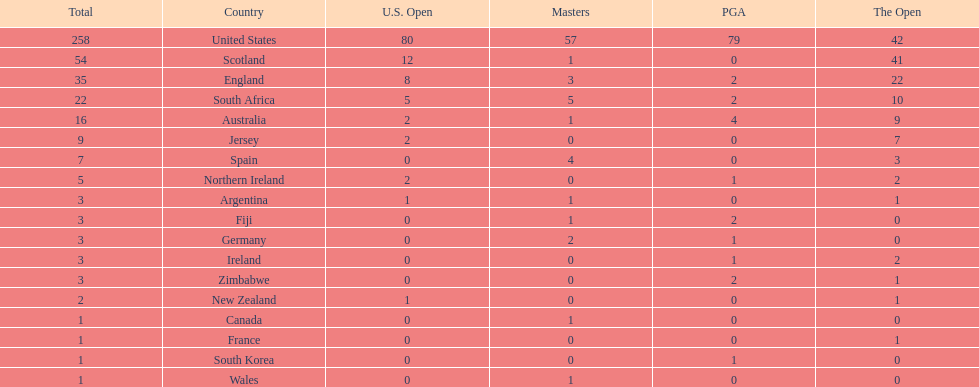Which country has the most pga championships. United States. Can you give me this table as a dict? {'header': ['Total', 'Country', 'U.S. Open', 'Masters', 'PGA', 'The Open'], 'rows': [['258', 'United States', '80', '57', '79', '42'], ['54', 'Scotland', '12', '1', '0', '41'], ['35', 'England', '8', '3', '2', '22'], ['22', 'South Africa', '5', '5', '2', '10'], ['16', 'Australia', '2', '1', '4', '9'], ['9', 'Jersey', '2', '0', '0', '7'], ['7', 'Spain', '0', '4', '0', '3'], ['5', 'Northern Ireland', '2', '0', '1', '2'], ['3', 'Argentina', '1', '1', '0', '1'], ['3', 'Fiji', '0', '1', '2', '0'], ['3', 'Germany', '0', '2', '1', '0'], ['3', 'Ireland', '0', '0', '1', '2'], ['3', 'Zimbabwe', '0', '0', '2', '1'], ['2', 'New Zealand', '1', '0', '0', '1'], ['1', 'Canada', '0', '1', '0', '0'], ['1', 'France', '0', '0', '0', '1'], ['1', 'South Korea', '0', '0', '1', '0'], ['1', 'Wales', '0', '1', '0', '0']]} 